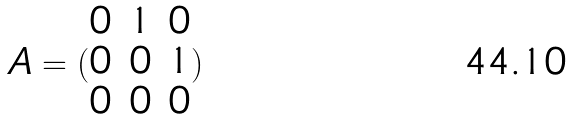Convert formula to latex. <formula><loc_0><loc_0><loc_500><loc_500>A = ( \begin{matrix} 0 & 1 & 0 \\ 0 & 0 & 1 \\ 0 & 0 & 0 \end{matrix} )</formula> 